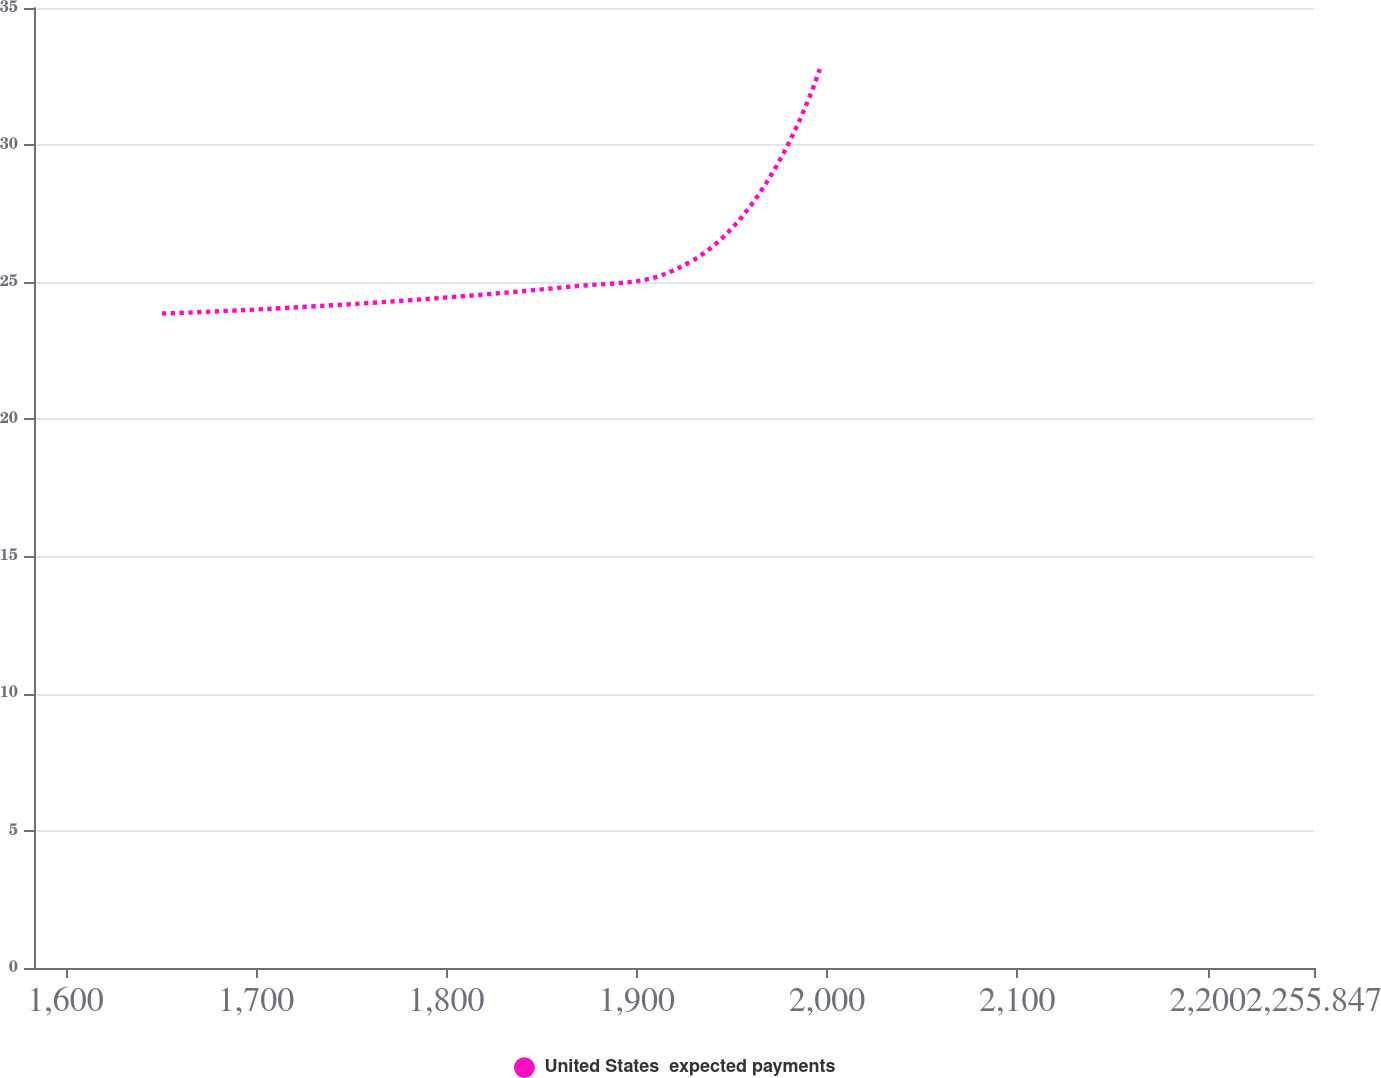Convert chart to OTSL. <chart><loc_0><loc_0><loc_500><loc_500><line_chart><ecel><fcel>United States  expected payments<nl><fcel>1650.66<fcel>23.86<nl><fcel>1861.82<fcel>24.82<nl><fcel>1929.06<fcel>25.78<nl><fcel>1996.3<fcel>32.79<nl><fcel>2323.09<fcel>33.75<nl></chart> 